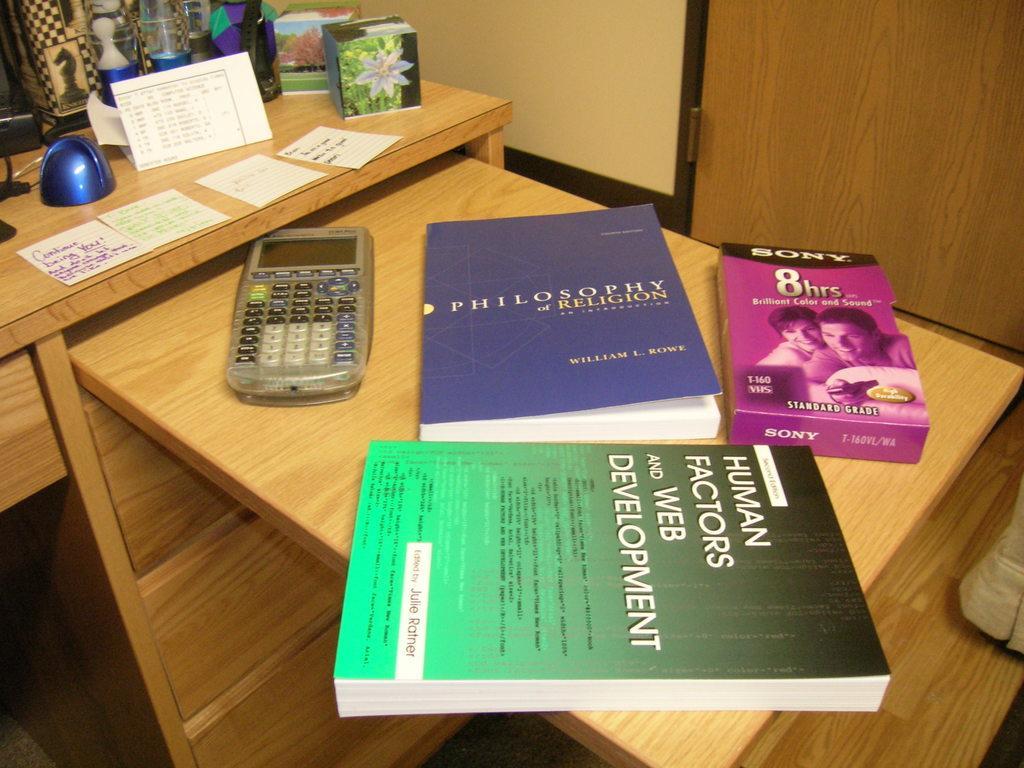Describe this image in one or two sentences. In this picture we can see table and on table we have books, calculator, cards, box, glass bottle, chess coin symbol and below this we have racks. 